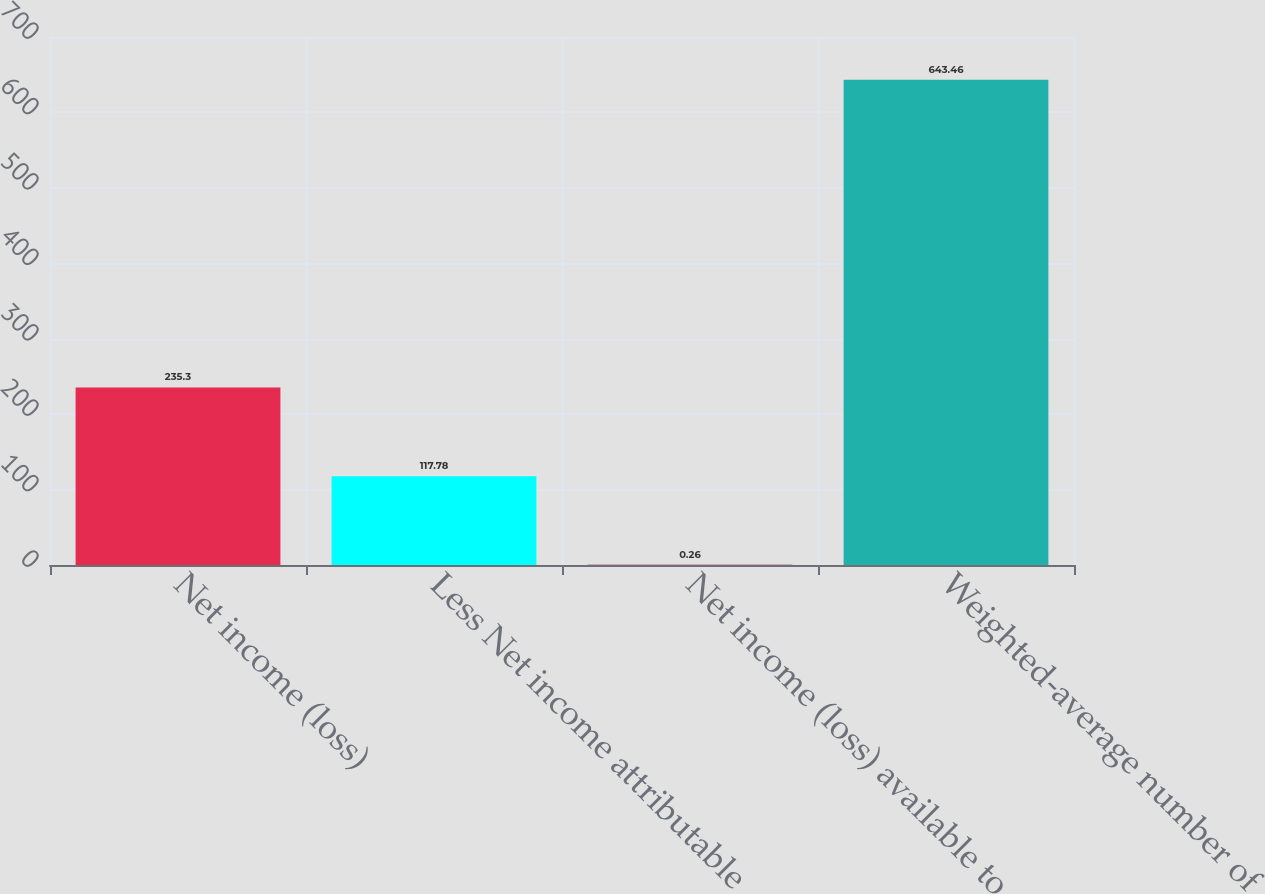Convert chart. <chart><loc_0><loc_0><loc_500><loc_500><bar_chart><fcel>Net income (loss)<fcel>Less Net income attributable<fcel>Net income (loss) available to<fcel>Weighted-average number of<nl><fcel>235.3<fcel>117.78<fcel>0.26<fcel>643.46<nl></chart> 